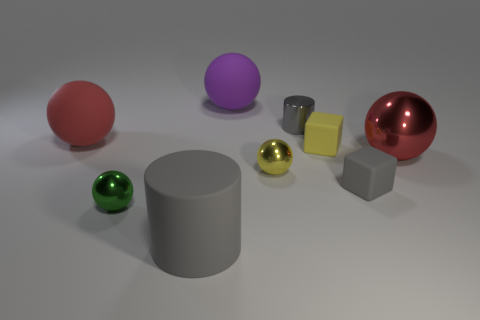Subtract all small yellow balls. How many balls are left? 4 Subtract all yellow blocks. How many red balls are left? 2 Subtract all red balls. How many balls are left? 3 Add 1 small yellow matte blocks. How many objects exist? 10 Add 2 large rubber spheres. How many large rubber spheres are left? 4 Add 1 small gray rubber cylinders. How many small gray rubber cylinders exist? 1 Subtract 2 red balls. How many objects are left? 7 Subtract all cylinders. How many objects are left? 7 Subtract all gray spheres. Subtract all red blocks. How many spheres are left? 5 Subtract all matte spheres. Subtract all purple balls. How many objects are left? 6 